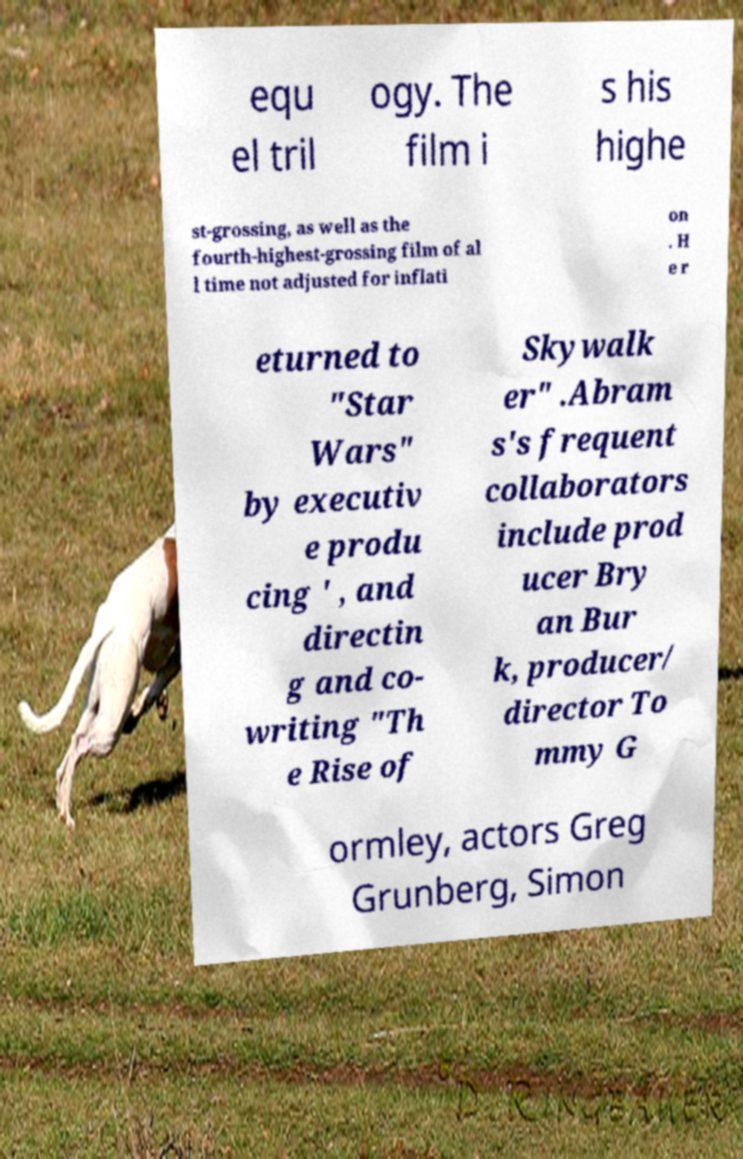Please identify and transcribe the text found in this image. equ el tril ogy. The film i s his highe st-grossing, as well as the fourth-highest-grossing film of al l time not adjusted for inflati on . H e r eturned to "Star Wars" by executiv e produ cing ' , and directin g and co- writing "Th e Rise of Skywalk er" .Abram s's frequent collaborators include prod ucer Bry an Bur k, producer/ director To mmy G ormley, actors Greg Grunberg, Simon 